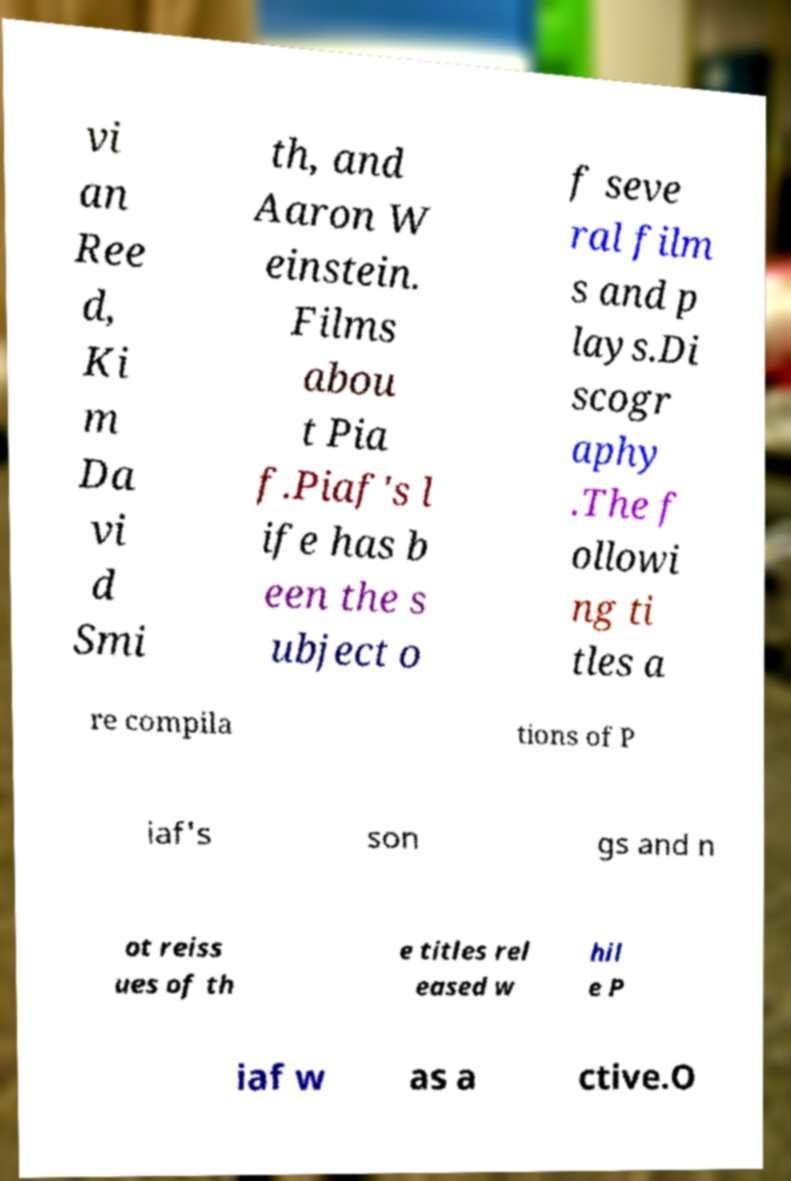Can you read and provide the text displayed in the image?This photo seems to have some interesting text. Can you extract and type it out for me? vi an Ree d, Ki m Da vi d Smi th, and Aaron W einstein. Films abou t Pia f.Piaf's l ife has b een the s ubject o f seve ral film s and p lays.Di scogr aphy .The f ollowi ng ti tles a re compila tions of P iaf's son gs and n ot reiss ues of th e titles rel eased w hil e P iaf w as a ctive.O 